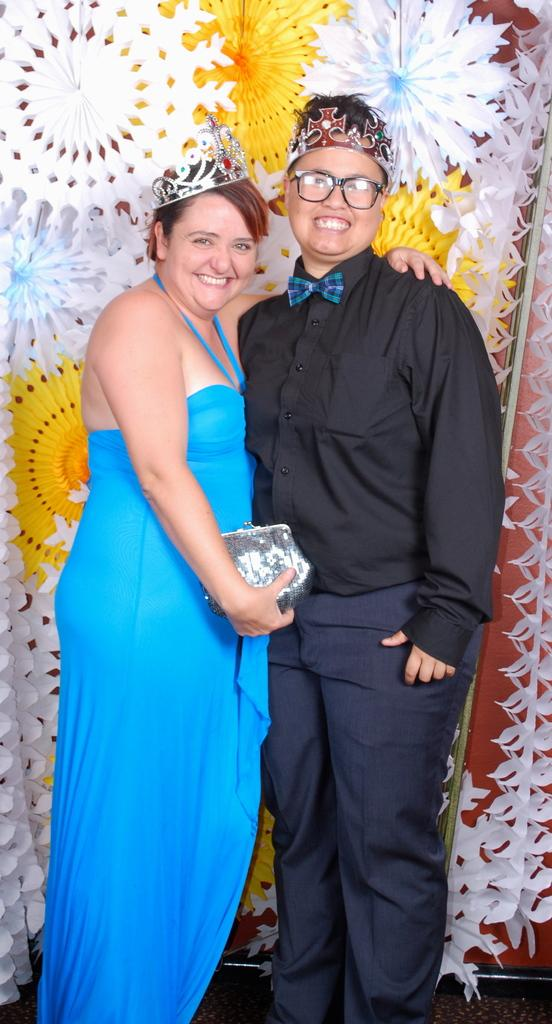How many people are in the image? There are two persons standing in the image. What is the facial expression of the people in the image? The two persons are smiling. What can be seen in the background of the image? There are colorful objects in the background of the image. Is this a family photo, and are there any afterthoughts in the garden? There is no information about the relationship between the two persons in the image, nor is there any mention of a garden or afterthoughts. 